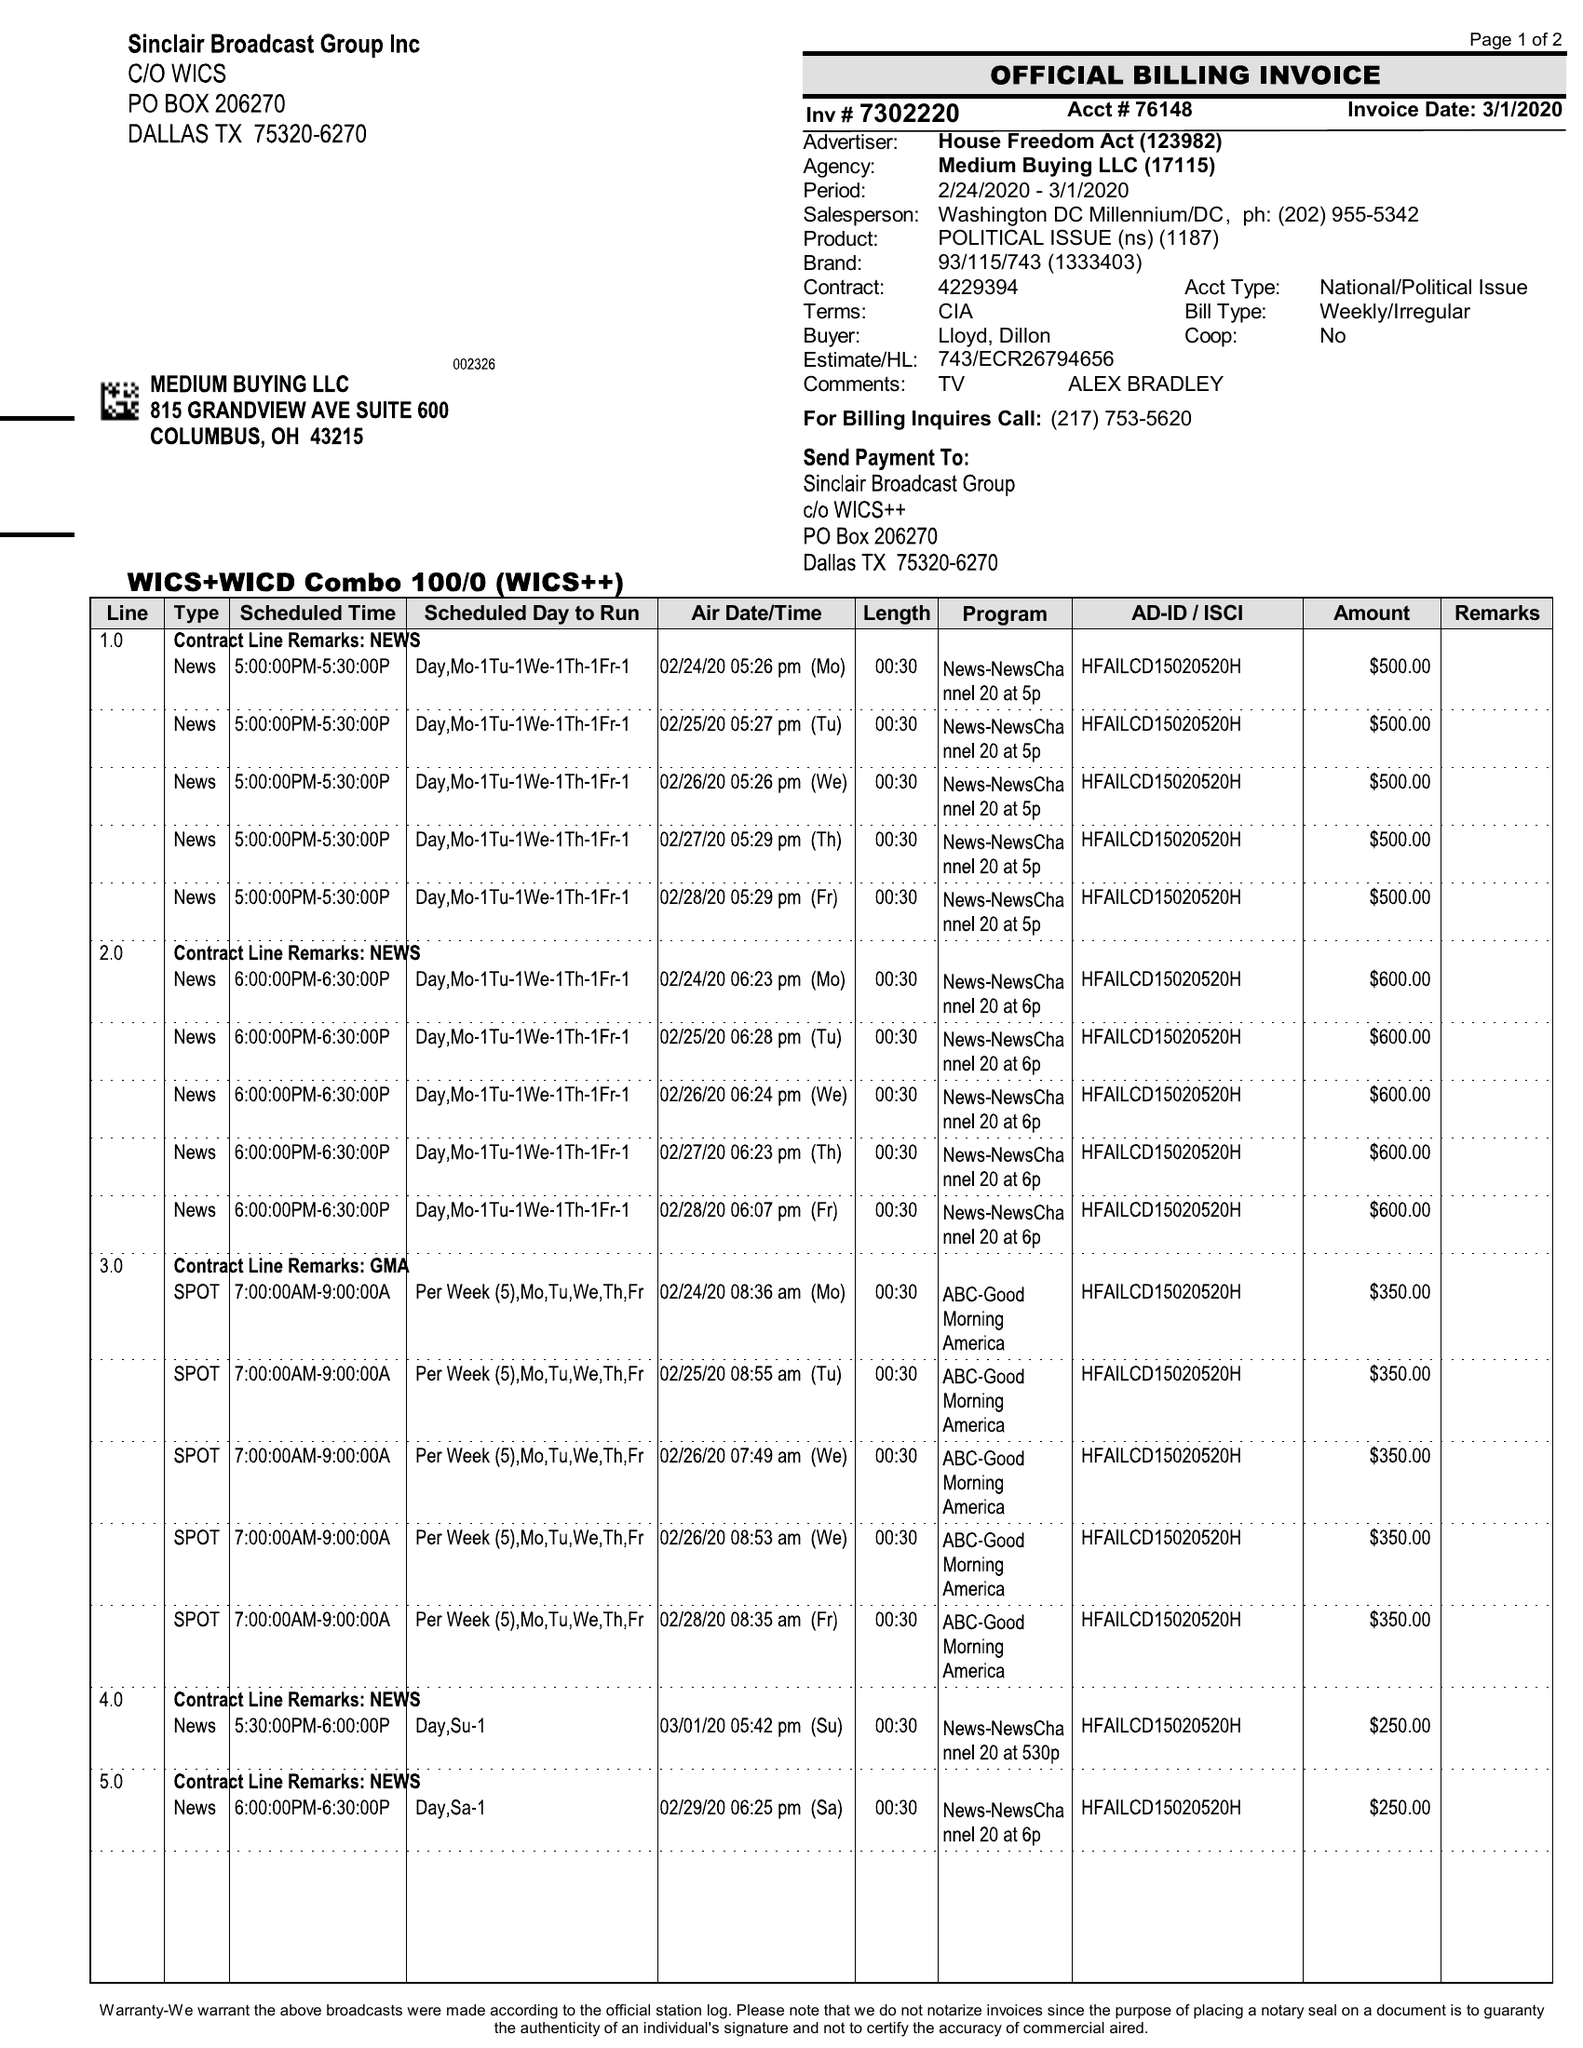What is the value for the flight_to?
Answer the question using a single word or phrase. 03/01/20 